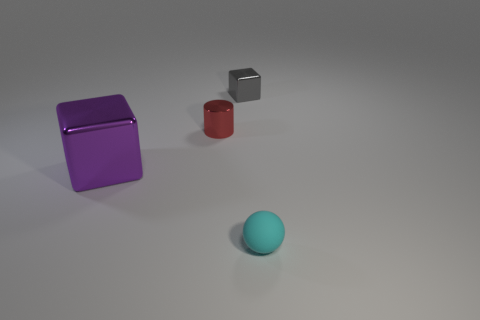Are there any other things that are the same size as the purple shiny block?
Offer a very short reply. No. What is the purple block made of?
Ensure brevity in your answer.  Metal. There is a tiny gray shiny thing that is behind the metallic cylinder; what is its shape?
Make the answer very short. Cube. Is there a purple metal block of the same size as the gray thing?
Make the answer very short. No. Do the block behind the large purple metallic object and the tiny ball have the same material?
Your answer should be very brief. No. Is the number of tiny cyan things that are behind the large purple block the same as the number of small red objects behind the shiny cylinder?
Make the answer very short. Yes. There is a tiny object that is right of the cylinder and behind the large purple metal cube; what is its shape?
Make the answer very short. Cube. How many metal things are behind the red metal object?
Provide a short and direct response. 1. How many other things are the same shape as the big object?
Your response must be concise. 1. Is the number of big metal blocks less than the number of brown metal cylinders?
Provide a succinct answer. No. 